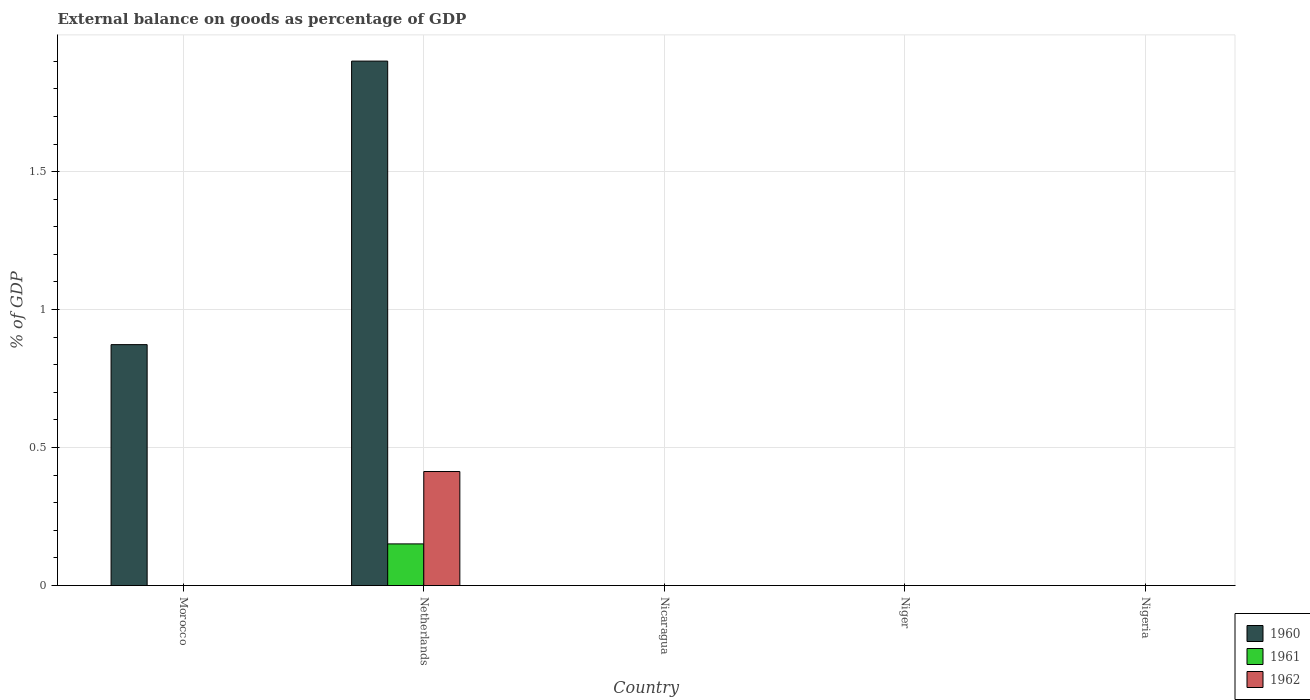Are the number of bars per tick equal to the number of legend labels?
Give a very brief answer. No. How many bars are there on the 4th tick from the left?
Offer a very short reply. 0. How many bars are there on the 4th tick from the right?
Your answer should be compact. 3. In how many cases, is the number of bars for a given country not equal to the number of legend labels?
Ensure brevity in your answer.  4. What is the external balance on goods as percentage of GDP in 1961 in Netherlands?
Keep it short and to the point. 0.15. Across all countries, what is the maximum external balance on goods as percentage of GDP in 1962?
Provide a succinct answer. 0.41. What is the total external balance on goods as percentage of GDP in 1960 in the graph?
Offer a very short reply. 2.77. What is the difference between the external balance on goods as percentage of GDP in 1960 in Niger and the external balance on goods as percentage of GDP in 1962 in Morocco?
Offer a terse response. 0. What is the average external balance on goods as percentage of GDP in 1962 per country?
Make the answer very short. 0.08. What is the difference between the external balance on goods as percentage of GDP of/in 1960 and external balance on goods as percentage of GDP of/in 1961 in Netherlands?
Provide a short and direct response. 1.75. What is the difference between the highest and the lowest external balance on goods as percentage of GDP in 1961?
Make the answer very short. 0.15. How many bars are there?
Your answer should be very brief. 4. Are all the bars in the graph horizontal?
Give a very brief answer. No. Are the values on the major ticks of Y-axis written in scientific E-notation?
Keep it short and to the point. No. Does the graph contain any zero values?
Your response must be concise. Yes. Where does the legend appear in the graph?
Provide a succinct answer. Bottom right. How many legend labels are there?
Give a very brief answer. 3. What is the title of the graph?
Your response must be concise. External balance on goods as percentage of GDP. What is the label or title of the Y-axis?
Provide a short and direct response. % of GDP. What is the % of GDP of 1960 in Morocco?
Your answer should be very brief. 0.87. What is the % of GDP of 1961 in Morocco?
Give a very brief answer. 0. What is the % of GDP in 1962 in Morocco?
Ensure brevity in your answer.  0. What is the % of GDP of 1960 in Netherlands?
Ensure brevity in your answer.  1.9. What is the % of GDP in 1961 in Netherlands?
Your answer should be compact. 0.15. What is the % of GDP of 1962 in Netherlands?
Ensure brevity in your answer.  0.41. What is the % of GDP of 1960 in Nicaragua?
Make the answer very short. 0. What is the % of GDP of 1961 in Nicaragua?
Ensure brevity in your answer.  0. What is the % of GDP in 1962 in Nicaragua?
Provide a short and direct response. 0. What is the % of GDP of 1962 in Niger?
Offer a very short reply. 0. What is the % of GDP of 1960 in Nigeria?
Make the answer very short. 0. What is the % of GDP in 1962 in Nigeria?
Ensure brevity in your answer.  0. Across all countries, what is the maximum % of GDP of 1960?
Your answer should be compact. 1.9. Across all countries, what is the maximum % of GDP of 1961?
Your response must be concise. 0.15. Across all countries, what is the maximum % of GDP of 1962?
Provide a short and direct response. 0.41. What is the total % of GDP of 1960 in the graph?
Keep it short and to the point. 2.77. What is the total % of GDP of 1961 in the graph?
Keep it short and to the point. 0.15. What is the total % of GDP in 1962 in the graph?
Your answer should be very brief. 0.41. What is the difference between the % of GDP in 1960 in Morocco and that in Netherlands?
Make the answer very short. -1.03. What is the difference between the % of GDP of 1960 in Morocco and the % of GDP of 1961 in Netherlands?
Keep it short and to the point. 0.72. What is the difference between the % of GDP in 1960 in Morocco and the % of GDP in 1962 in Netherlands?
Keep it short and to the point. 0.46. What is the average % of GDP of 1960 per country?
Make the answer very short. 0.55. What is the average % of GDP in 1961 per country?
Offer a very short reply. 0.03. What is the average % of GDP in 1962 per country?
Your answer should be very brief. 0.08. What is the difference between the % of GDP in 1960 and % of GDP in 1961 in Netherlands?
Your answer should be very brief. 1.75. What is the difference between the % of GDP in 1960 and % of GDP in 1962 in Netherlands?
Your answer should be compact. 1.49. What is the difference between the % of GDP of 1961 and % of GDP of 1962 in Netherlands?
Provide a short and direct response. -0.26. What is the ratio of the % of GDP in 1960 in Morocco to that in Netherlands?
Provide a succinct answer. 0.46. What is the difference between the highest and the lowest % of GDP in 1960?
Your response must be concise. 1.9. What is the difference between the highest and the lowest % of GDP in 1961?
Your answer should be compact. 0.15. What is the difference between the highest and the lowest % of GDP in 1962?
Your response must be concise. 0.41. 